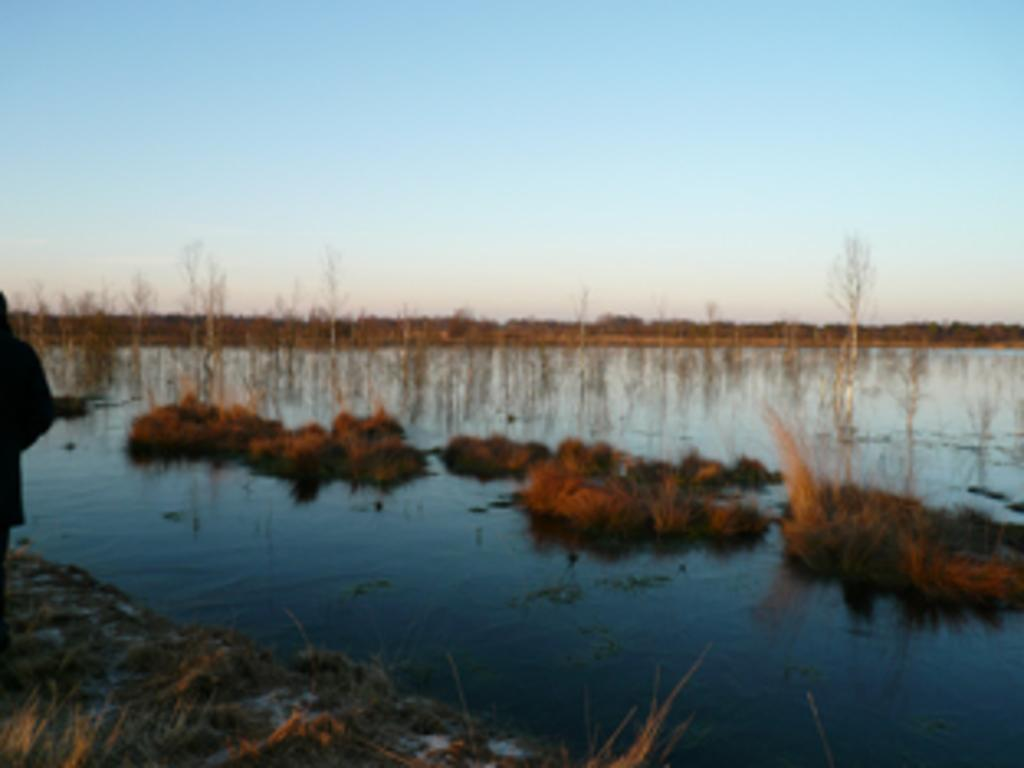What body of water is visible in the image? There is a lake in the image. What type of vegetation is near the lake? There is grass and plants near the lake. What type of furniture is visible near the lake in the image? There is no furniture visible near the lake in the image. 